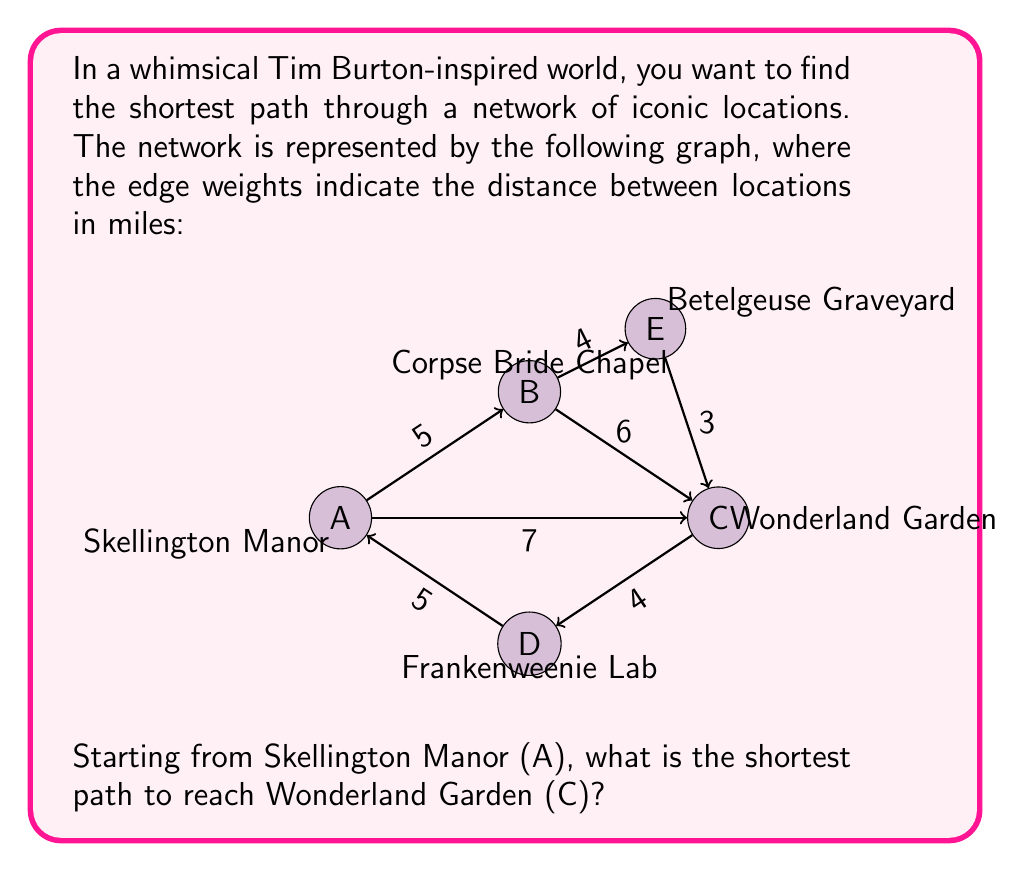Give your solution to this math problem. To solve this problem, we'll use Dijkstra's algorithm to find the shortest path from vertex A to vertex C.

Step 1: Initialize distances
Let $d(v)$ be the distance from A to vertex $v$.
$d(A) = 0$
$d(B) = d(C) = d(D) = d(E) = \infty$

Step 2: Visit vertex A
Update distances:
$d(B) = \min(d(B), d(A) + 5) = 5$
$d(C) = \min(d(C), d(A) + 7) = 7$
$d(D) = \min(d(D), d(A) + 5) = 5$

Step 3: Visit vertex B (closest unvisited vertex)
Update distances:
$d(C) = \min(d(C), d(B) + 6) = \min(7, 11) = 7$
$d(E) = \min(d(E), d(B) + 4) = 9$

Step 4: Visit vertex D (next closest unvisited vertex)
Update distances:
$d(C) = \min(d(C), d(D) + 4) = \min(7, 9) = 7$

Step 5: Visit vertex C (next closest unvisited vertex)
We've reached our destination, so we can stop.

The shortest path from A to C has a distance of 7 miles. To determine the actual path, we backtrack:

C came from A directly (7 miles)

Therefore, the shortest path is A → C, which corresponds to Skellington Manor → Wonderland Garden.
Answer: Skellington Manor → Wonderland Garden (7 miles) 